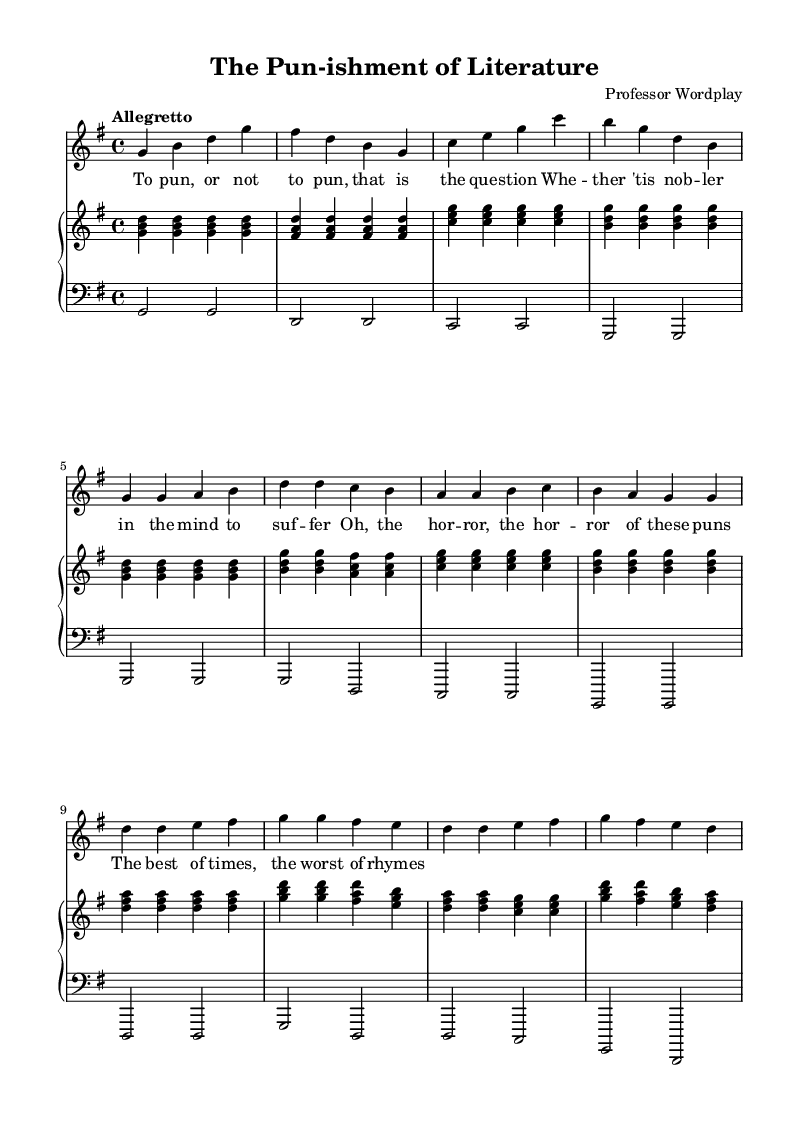What is the key signature of this music? The key signature is G major, which has one sharp (F#). This can be identified by looking at the key signature indicated at the beginning of the sheet music.
Answer: G major What is the time signature of this music? The time signature is 4/4, indicated at the beginning of the sheet music. This means there are four beats in each measure, with the quarter note receiving one beat.
Answer: 4/4 What is the tempo marking for this piece? The tempo marking is "Allegretto," which suggests a moderate tempo, typically ranging from 98 to 109 beats per minute. This can be found written above the staff at the start of the music.
Answer: Allegretto How many measures are in the introduction section? The introduction consists of four measures, which can be counted directly from the section where the measures are outlined. Each set of four quarter notes indicates a single measure.
Answer: 4 What literary reference is made in the lyrics? The lyrics include a reference to Shakespeare's "Hamlet," specifically the famous line "To be, or not to be." This can be recognized as it paraphrases a well-known quote from the play.
Answer: Hamlet How many verses are in the piece? The piece contains one verse, which is indicated in the structure presented in the music. There is a clear separation between the verse and the chorus, denoting it as a single verse.
Answer: 1 What is the overall mood suggested by the music and lyrics? The overall mood suggested by the music and lyrics is comedic. This can be inferred from the playful nature of the lyrics that include puns and humor alongside the light and lively tempo.
Answer: Comedic 